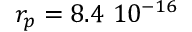<formula> <loc_0><loc_0><loc_500><loc_500>r _ { p } = 8 . 4 1 0 ^ { - 1 6 }</formula> 